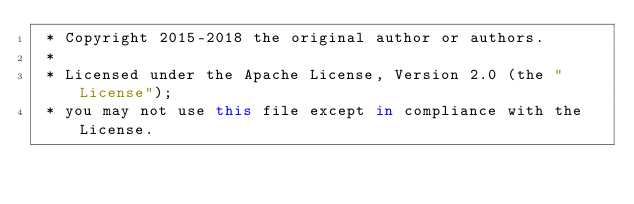<code> <loc_0><loc_0><loc_500><loc_500><_Kotlin_> * Copyright 2015-2018 the original author or authors.
 *
 * Licensed under the Apache License, Version 2.0 (the "License");
 * you may not use this file except in compliance with the License.</code> 